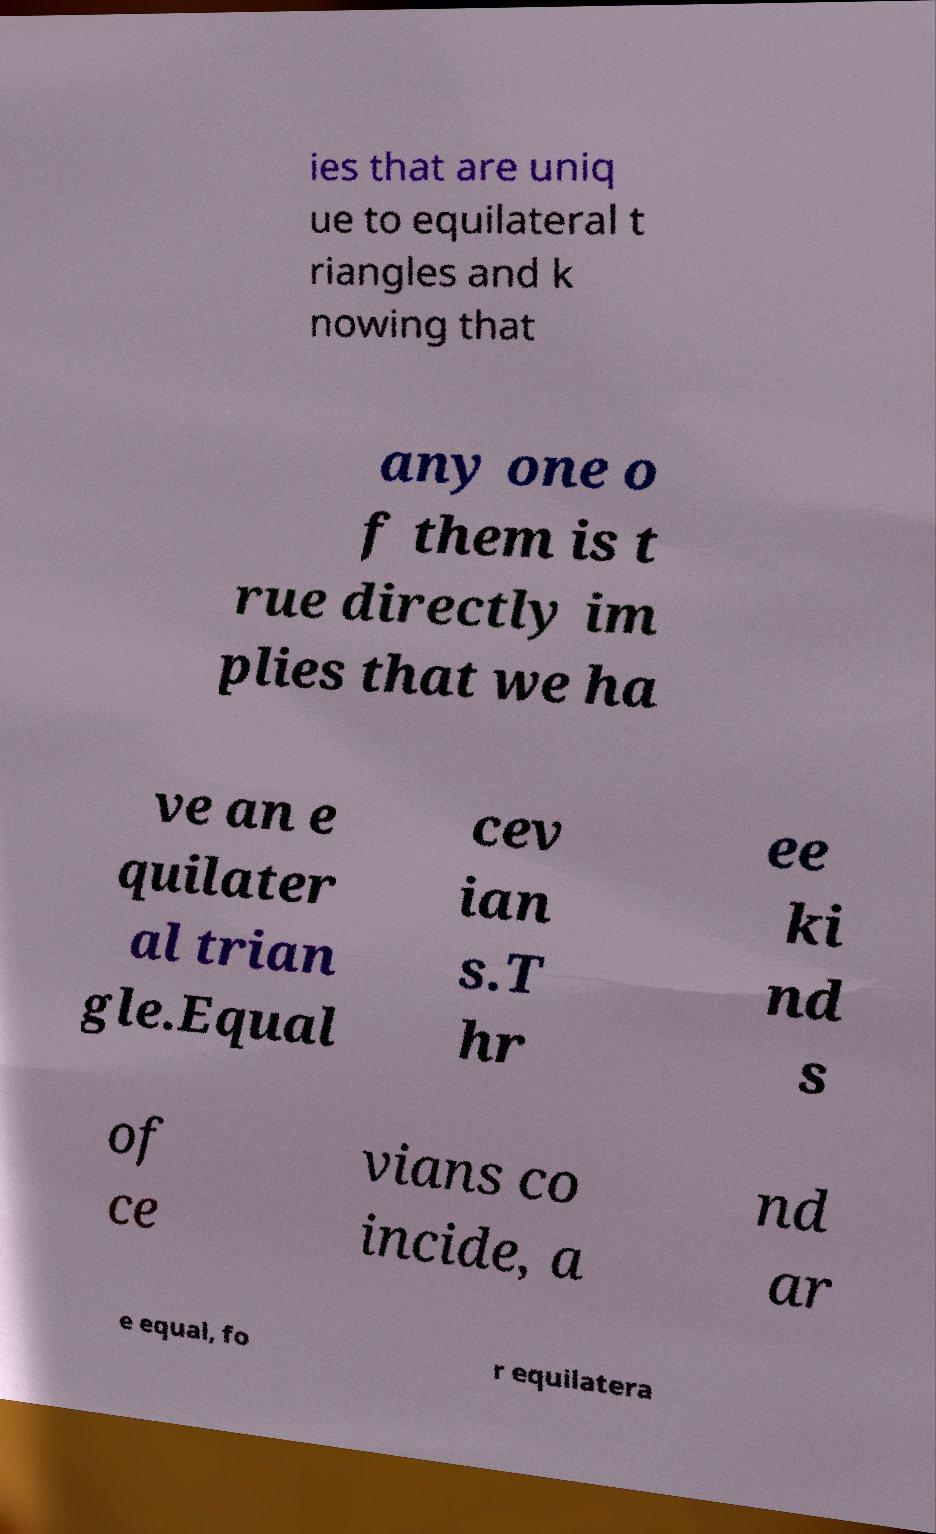Please identify and transcribe the text found in this image. ies that are uniq ue to equilateral t riangles and k nowing that any one o f them is t rue directly im plies that we ha ve an e quilater al trian gle.Equal cev ian s.T hr ee ki nd s of ce vians co incide, a nd ar e equal, fo r equilatera 